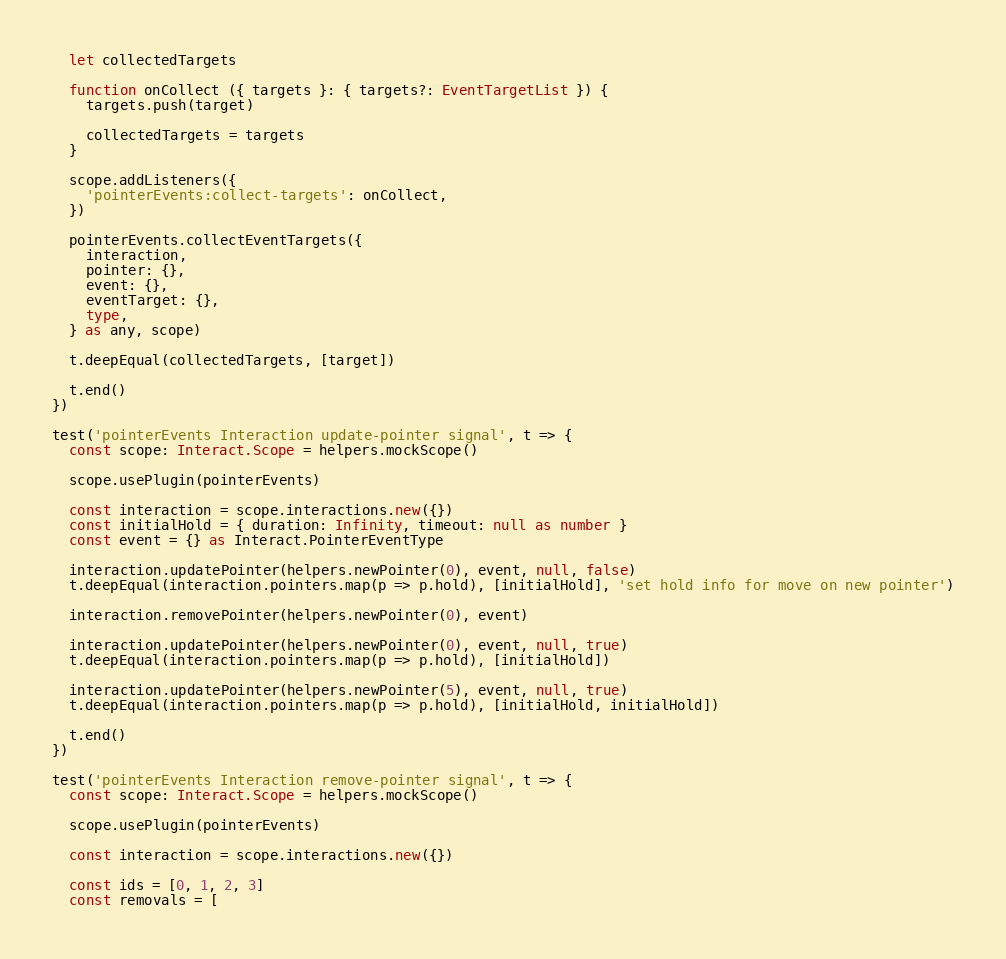Convert code to text. <code><loc_0><loc_0><loc_500><loc_500><_TypeScript_>  let collectedTargets

  function onCollect ({ targets }: { targets?: EventTargetList }) {
    targets.push(target)

    collectedTargets = targets
  }

  scope.addListeners({
    'pointerEvents:collect-targets': onCollect,
  })

  pointerEvents.collectEventTargets({
    interaction,
    pointer: {},
    event: {},
    eventTarget: {},
    type,
  } as any, scope)

  t.deepEqual(collectedTargets, [target])

  t.end()
})

test('pointerEvents Interaction update-pointer signal', t => {
  const scope: Interact.Scope = helpers.mockScope()

  scope.usePlugin(pointerEvents)

  const interaction = scope.interactions.new({})
  const initialHold = { duration: Infinity, timeout: null as number }
  const event = {} as Interact.PointerEventType

  interaction.updatePointer(helpers.newPointer(0), event, null, false)
  t.deepEqual(interaction.pointers.map(p => p.hold), [initialHold], 'set hold info for move on new pointer')

  interaction.removePointer(helpers.newPointer(0), event)

  interaction.updatePointer(helpers.newPointer(0), event, null, true)
  t.deepEqual(interaction.pointers.map(p => p.hold), [initialHold])

  interaction.updatePointer(helpers.newPointer(5), event, null, true)
  t.deepEqual(interaction.pointers.map(p => p.hold), [initialHold, initialHold])

  t.end()
})

test('pointerEvents Interaction remove-pointer signal', t => {
  const scope: Interact.Scope = helpers.mockScope()

  scope.usePlugin(pointerEvents)

  const interaction = scope.interactions.new({})

  const ids = [0, 1, 2, 3]
  const removals = [</code> 